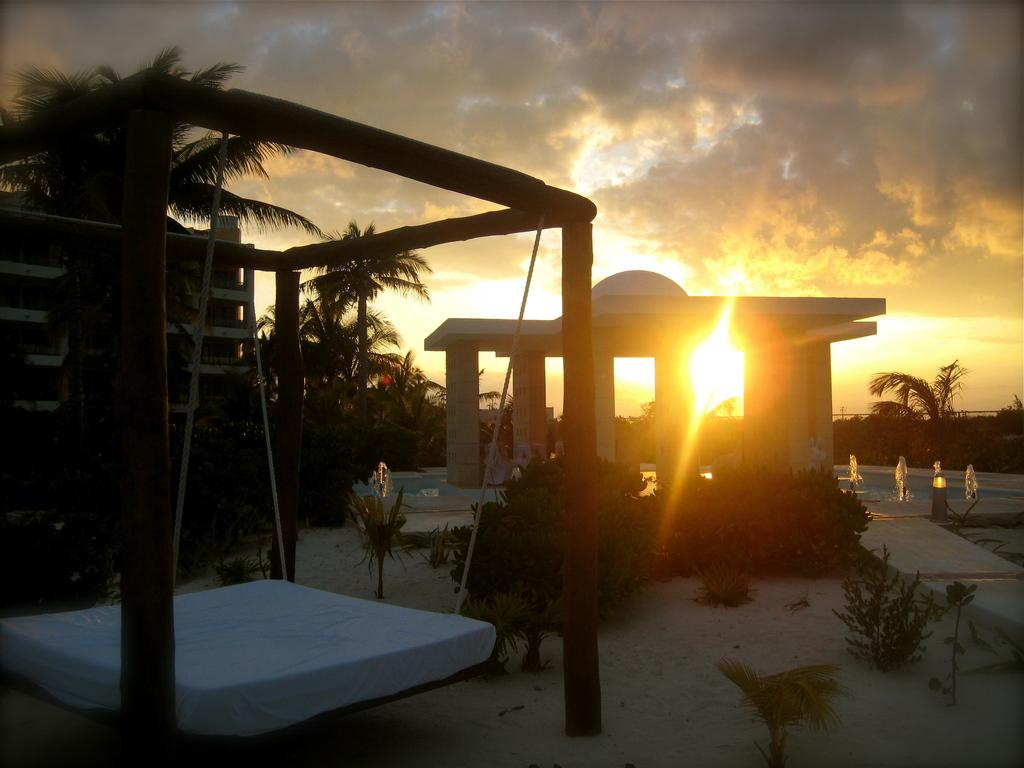What type of vegetation can be seen in the image? There are trees in the image. What architectural elements are present in the image? There are pillars in the image. What tool is visible in the image? There is a ladder in the image. What type of furniture is present in the image? There is a bed in the image. What other living organisms can be seen in the image? There are plants in the image. What part of the natural environment is visible in the image? The sky is visible in the image. Can you see a fingerprint on the ladder in the image? There is no mention of a fingerprint or any indication that a fingerprint is present in the image. --- Facts: 1. There is a car in the image. 2. The car is red. 3. There are people in the car. 4. The car has four wheels. 5. The car has a license plate. Absurd Topics: bird, ocean, mountain Conversation: What type of vehicle is in the image? There is a car in the image. What color is the car? The car is red. Who is inside the car? There are people in the car. How many wheels does the car have? The car has four wheels. Does the car have any identifying features? Yes, the car has a license plate. Reasoning: Let's think step by step in order to produce the conversation. We start by identifying the main subject in the image, which is the car. Then, we expand the conversation to include other details about the car, such as its color, the presence of people inside, the number of wheels, and the license plate. Each question is designed to elicit a specific detail about the image that is known from the provided facts. Absurd Question/Answer: Can you see any birds flying over the ocean in the image? There is no mention of birds, an ocean, or any other landscape features in the image; it only features a red car with people inside. 